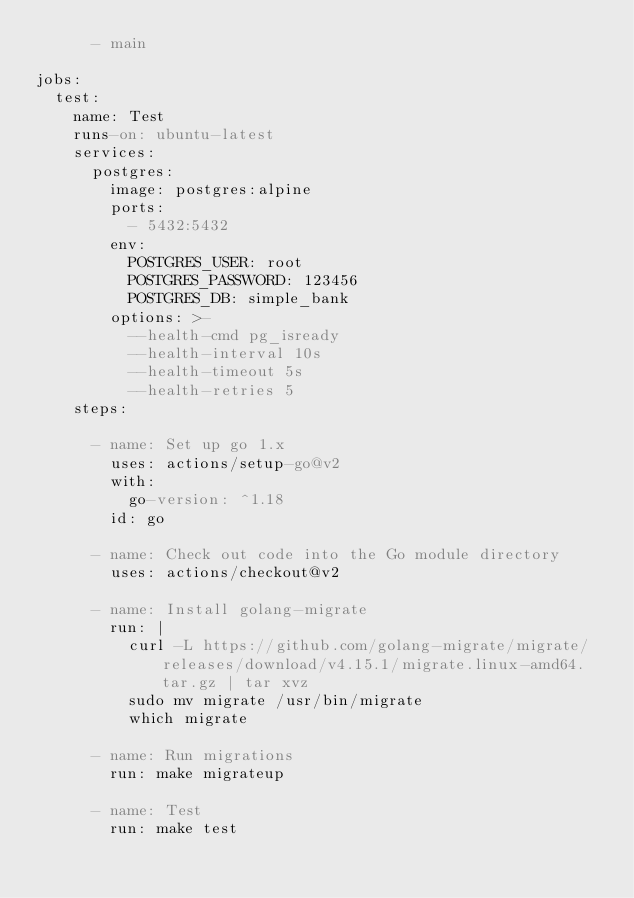<code> <loc_0><loc_0><loc_500><loc_500><_YAML_>      - main

jobs:
  test:
    name: Test
    runs-on: ubuntu-latest
    services:
      postgres:
        image: postgres:alpine
        ports:
          - 5432:5432
        env:
          POSTGRES_USER: root
          POSTGRES_PASSWORD: 123456
          POSTGRES_DB: simple_bank
        options: >-
          --health-cmd pg_isready
          --health-interval 10s
          --health-timeout 5s
          --health-retries 5
    steps:

      - name: Set up go 1.x
        uses: actions/setup-go@v2
        with:
          go-version: ^1.18
        id: go

      - name: Check out code into the Go module directory
        uses: actions/checkout@v2

      - name: Install golang-migrate
        run: |
          curl -L https://github.com/golang-migrate/migrate/releases/download/v4.15.1/migrate.linux-amd64.tar.gz | tar xvz
          sudo mv migrate /usr/bin/migrate
          which migrate

      - name: Run migrations
        run: make migrateup

      - name: Test
        run: make test</code> 